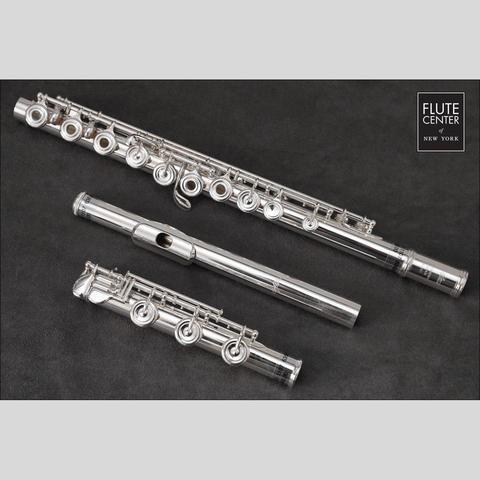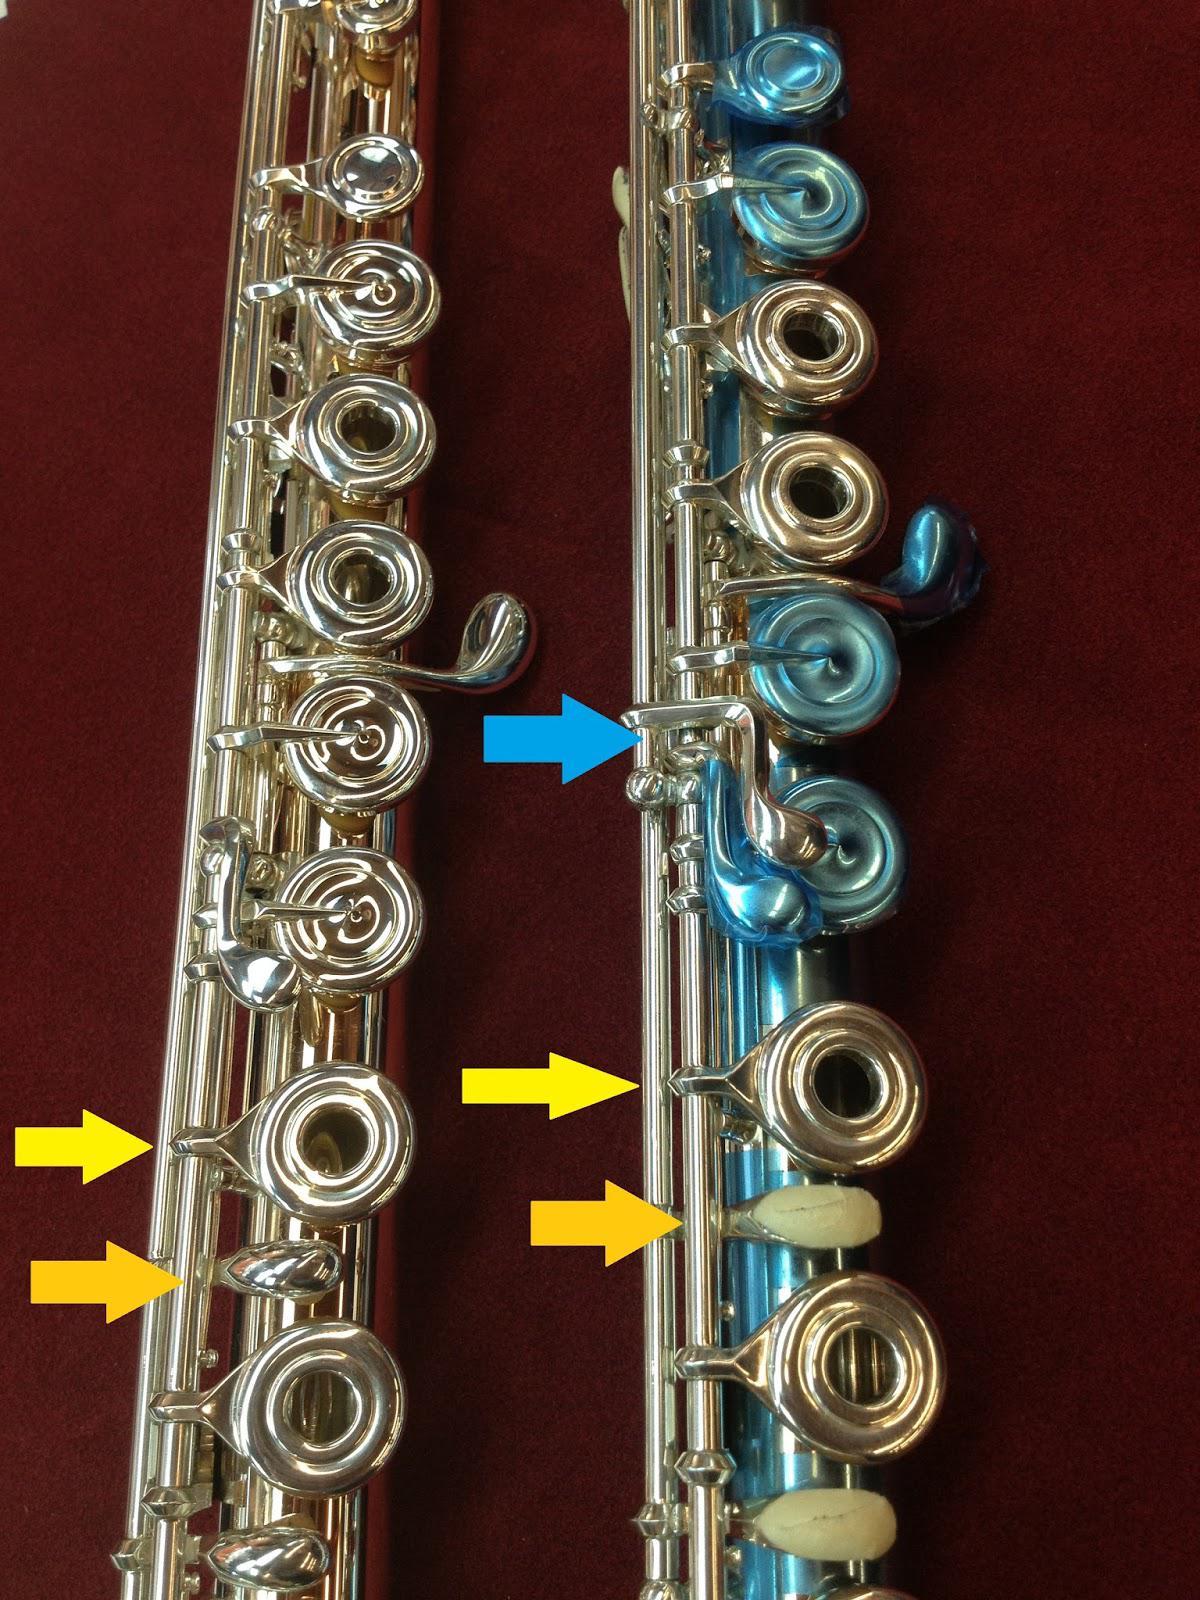The first image is the image on the left, the second image is the image on the right. Examine the images to the left and right. Is the description "One image shows a disassembled instrument in an open case displayed horizontally, and the other image shows items that are not in a case." accurate? Answer yes or no. No. The first image is the image on the left, the second image is the image on the right. For the images shown, is this caption "One of the flutes is blue." true? Answer yes or no. Yes. 